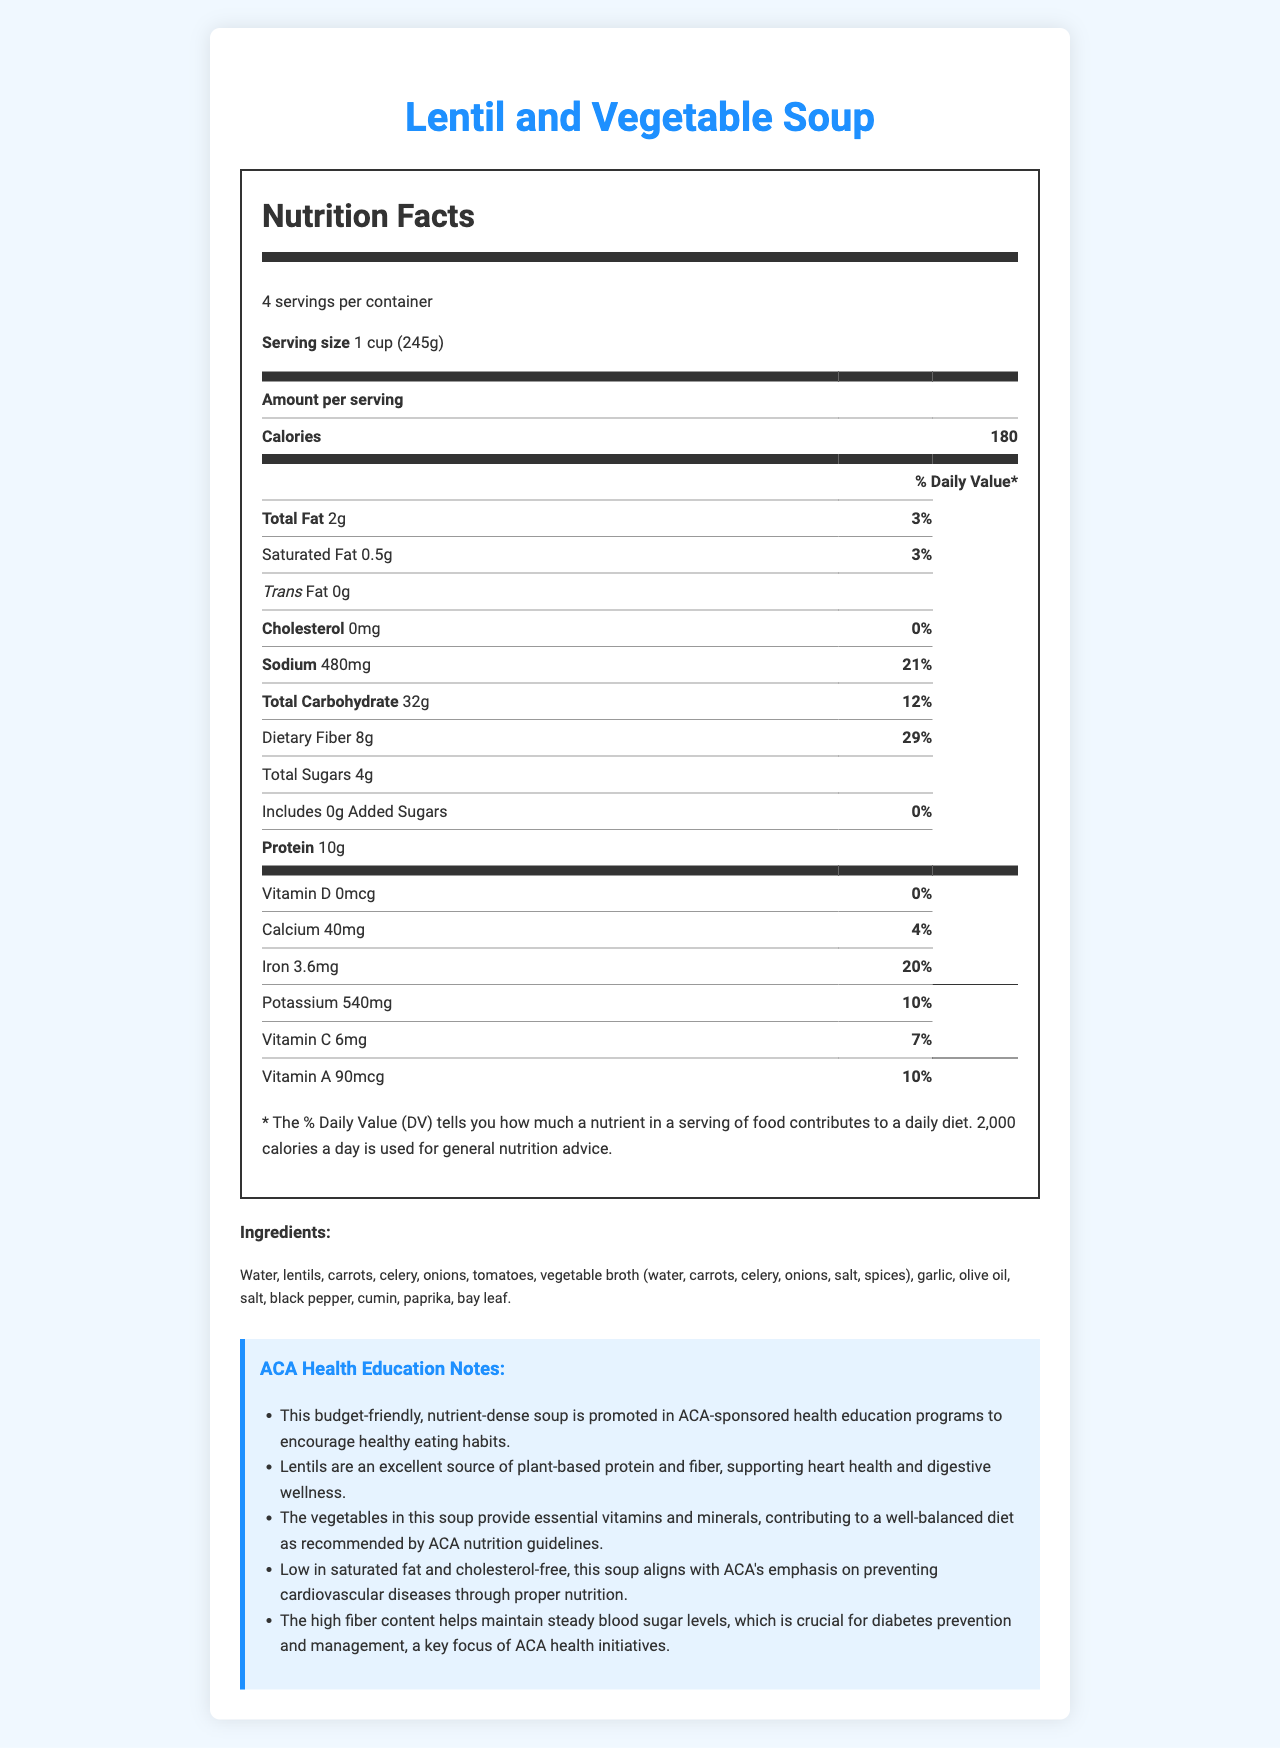what is the serving size of the Lentil and Vegetable Soup? The serving size is clearly stated as "1 cup (245g)" in the Nutrition Facts section.
Answer: 1 cup (245g) how many calories are in one serving of the soup? The document mentions that there are 180 calories per serving.
Answer: 180 What percentage of the Daily Value does the sodium content contribute? The sodium content is listed as 480mg, contributing 21% to the Daily Value.
Answer: 21% how much dietary fiber is in one serving of the soup? The Dietary Fiber amount is listed as 8g per serving.
Answer: 8g What are the primary ingredients in the soup? The ingredients section lists all the primary ingredients used in the soup.
Answer: Water, lentils, carrots, celery, onions, tomatoes, vegetable broth (water, carrots, celery, onions, salt, spices), garlic, olive oil, salt, black pepper, cumin, paprika, bay leaf. Which nutrient contributes the highest percentage to the Daily Value? A. Sodium B. Dietary Fiber C. Iron D. Calcium Dietary Fiber contributes 29% to the Daily Value, which is the highest percentage listed among the given options.
Answer: B. Dietary Fiber What is the % Daily Value for Iron? A. 4% B. 10% C. 20% D. 29% The Iron content is listed as 3.6mg, which contributes 20% to the Daily Value.
Answer: C. 20% Is the soup low in saturated fat? The soup contains only 0.5g of saturated fat, contributing 3% to the Daily Value, which is considered low.
Answer: Yes Summarize the main nutritional benefits of Lentil and Vegetable Soup as promoted by ACA. The summary combines the main points from the ACA Health Education Notes and the nutritional values presented, showing why the soup is promoted under ACA health programs.
Answer: The soup is budget-friendly and nutrient-dense, providing an excellent source of plant-based protein and fiber. It supports heart health, digestive wellness, and steady blood sugar levels. It's also low in saturated fat and cholesterol-free, aligning with ACA's focus on preventing cardiovascular diseases and managing diabetes. What is the impact of the soup's potassium content on daily nutrition? The potassium content of the soup is 540mg, which contributes 10% to the Daily Value.
Answer: 10% Daily Value How much added sugar is in one serving of the soup? The document states that there are no added sugars in the soup.
Answer: 0g Are lentils the first ingredient listed in the soup? The first ingredient listed is Water, followed by lentils.
Answer: No How much protein does one serving of the soup provide? The protein amount is specified as 10g per serving.
Answer: 10g What is the total amount of calcium in one serving of the soup? The document mentions that each serving contains 40mg of calcium, which contributes 4% to the Daily Value.
Answer: 40mg what are the benefits of the soup for individuals with diabetes? According to the ACA Health Education Notes, the high fiber content supports the maintenance of steady blood sugar levels.
Answer: The high fiber content helps maintain steady blood sugar levels, crucial for diabetes prevention and management. Why was the Lentil and Vegetable Soup chosen for promotion in ACA-sponsored programs? The ACA Health Education Notes highlight the suitability of the soup due to its nutritional benefits and alignment with health guidelines.
Answer: It is budget-friendly, nutrient-dense, supports heart and digestive health, manages blood sugar levels, and prevents cardiovascular diseases. What type of broth is used in the soup? The ingredients list specifies that the soup contains vegetable broth made from water, carrots, celery, onions, salt, and spices.
Answer: Vegetable broth How does the soup align with ACA guidelines on cardiovascular health? The soup contains only 0.5g of saturated fat and has no cholesterol, aligning with ACA's recommendation for cardiovascular health.
Answer: It is low in saturated fat and cholesterol-free. What is the total number of servings per container? The document states that there are 4 servings per container.
Answer: 4 What is the primary source of protein in the soup? According to the ingredients and ACA Health Education Notes, lentils are highlighted as an excellent source of plant-based protein.
Answer: Lentils How much total carbohydrate is in one serving of the soup? The total carbohydrate content per serving is listed as 32g.
Answer: 32g How much vitamin C does one serving contain? The document indicates that each serving contains 6mg of vitamin C, contributing 7% to the Daily Value.
Answer: 6mg What percentage of the Daily Value of calcium does the soup provide? The calcium content is 40mg per serving, contributing 4% to the Daily Value.
Answer: 4% What is the maximum amount of lentil consumption recommended per day? The document does not provide any specific recommendation on the maximum amount of lentil consumption per day.
Answer: Cannot be determined 